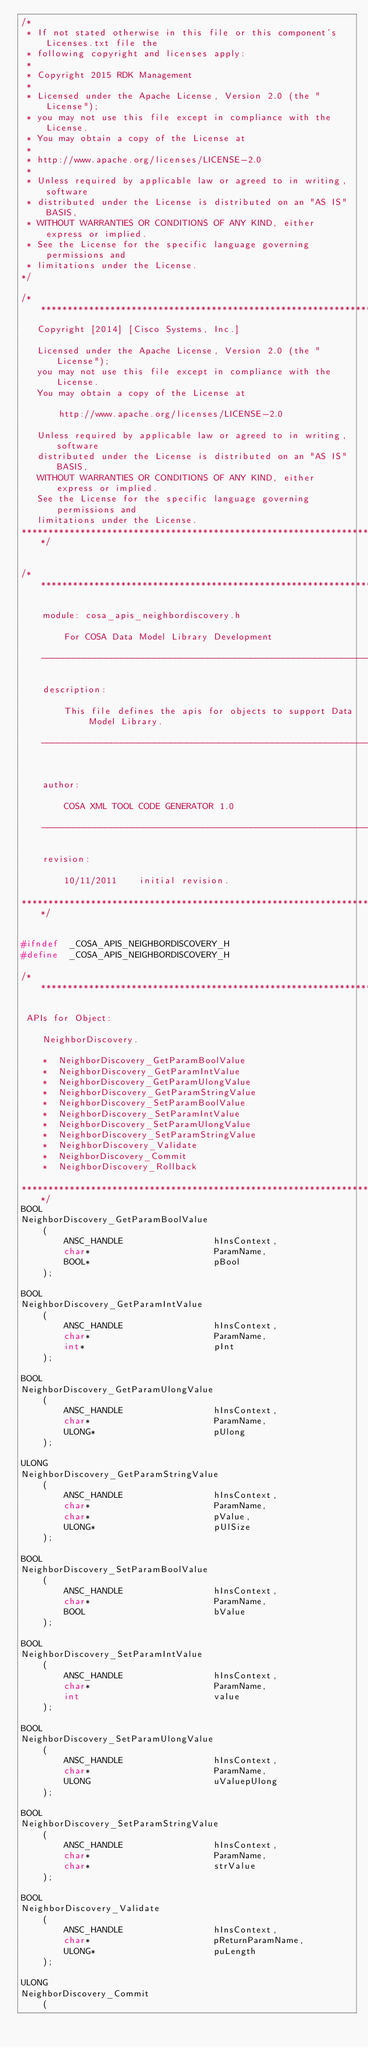<code> <loc_0><loc_0><loc_500><loc_500><_C_>/*
 * If not stated otherwise in this file or this component's Licenses.txt file the
 * following copyright and licenses apply:
 *
 * Copyright 2015 RDK Management
 *
 * Licensed under the Apache License, Version 2.0 (the "License");
 * you may not use this file except in compliance with the License.
 * You may obtain a copy of the License at
 *
 * http://www.apache.org/licenses/LICENSE-2.0
 *
 * Unless required by applicable law or agreed to in writing, software
 * distributed under the License is distributed on an "AS IS" BASIS,
 * WITHOUT WARRANTIES OR CONDITIONS OF ANY KIND, either express or implied.
 * See the License for the specific language governing permissions and
 * limitations under the License.
*/

/**********************************************************************
   Copyright [2014] [Cisco Systems, Inc.]
 
   Licensed under the Apache License, Version 2.0 (the "License");
   you may not use this file except in compliance with the License.
   You may obtain a copy of the License at
 
       http://www.apache.org/licenses/LICENSE-2.0
 
   Unless required by applicable law or agreed to in writing, software
   distributed under the License is distributed on an "AS IS" BASIS,
   WITHOUT WARRANTIES OR CONDITIONS OF ANY KIND, either express or implied.
   See the License for the specific language governing permissions and
   limitations under the License.
**********************************************************************/


/**************************************************************************

    module: cosa_apis_neighbordiscovery.h

        For COSA Data Model Library Development

    -------------------------------------------------------------------

    description:

        This file defines the apis for objects to support Data Model Library.

    -------------------------------------------------------------------


    author:

        COSA XML TOOL CODE GENERATOR 1.0

    -------------------------------------------------------------------

    revision:

        10/11/2011    initial revision.

**************************************************************************/


#ifndef  _COSA_APIS_NEIGHBORDISCOVERY_H
#define  _COSA_APIS_NEIGHBORDISCOVERY_H

/***********************************************************************

 APIs for Object:

    NeighborDiscovery.

    *  NeighborDiscovery_GetParamBoolValue
    *  NeighborDiscovery_GetParamIntValue
    *  NeighborDiscovery_GetParamUlongValue
    *  NeighborDiscovery_GetParamStringValue
    *  NeighborDiscovery_SetParamBoolValue
    *  NeighborDiscovery_SetParamIntValue
    *  NeighborDiscovery_SetParamUlongValue
    *  NeighborDiscovery_SetParamStringValue
    *  NeighborDiscovery_Validate
    *  NeighborDiscovery_Commit
    *  NeighborDiscovery_Rollback

***********************************************************************/
BOOL
NeighborDiscovery_GetParamBoolValue
    (
        ANSC_HANDLE                 hInsContext,
        char*                       ParamName,
        BOOL*                       pBool
    );

BOOL
NeighborDiscovery_GetParamIntValue
    (
        ANSC_HANDLE                 hInsContext,
        char*                       ParamName,
        int*                        pInt
    );

BOOL
NeighborDiscovery_GetParamUlongValue
    (
        ANSC_HANDLE                 hInsContext,
        char*                       ParamName,
        ULONG*                      pUlong
    );

ULONG
NeighborDiscovery_GetParamStringValue
    (
        ANSC_HANDLE                 hInsContext,
        char*                       ParamName,
        char*                       pValue,
        ULONG*                      pUlSize
    );

BOOL
NeighborDiscovery_SetParamBoolValue
    (
        ANSC_HANDLE                 hInsContext,
        char*                       ParamName,
        BOOL                        bValue
    );

BOOL
NeighborDiscovery_SetParamIntValue
    (
        ANSC_HANDLE                 hInsContext,
        char*                       ParamName,
        int                         value
    );

BOOL
NeighborDiscovery_SetParamUlongValue
    (
        ANSC_HANDLE                 hInsContext,
        char*                       ParamName,
        ULONG                       uValuepUlong
    );

BOOL
NeighborDiscovery_SetParamStringValue
    (
        ANSC_HANDLE                 hInsContext,
        char*                       ParamName,
        char*                       strValue
    );

BOOL
NeighborDiscovery_Validate
    (
        ANSC_HANDLE                 hInsContext,
        char*                       pReturnParamName,
        ULONG*                      puLength
    );

ULONG
NeighborDiscovery_Commit
    (</code> 